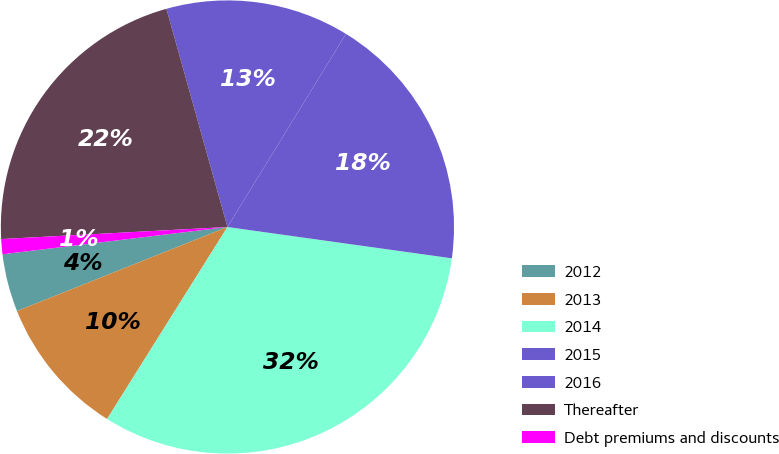Convert chart. <chart><loc_0><loc_0><loc_500><loc_500><pie_chart><fcel>2012<fcel>2013<fcel>2014<fcel>2015<fcel>2016<fcel>Thereafter<fcel>Debt premiums and discounts<nl><fcel>4.13%<fcel>10.04%<fcel>31.71%<fcel>18.45%<fcel>13.1%<fcel>21.51%<fcel>1.07%<nl></chart> 